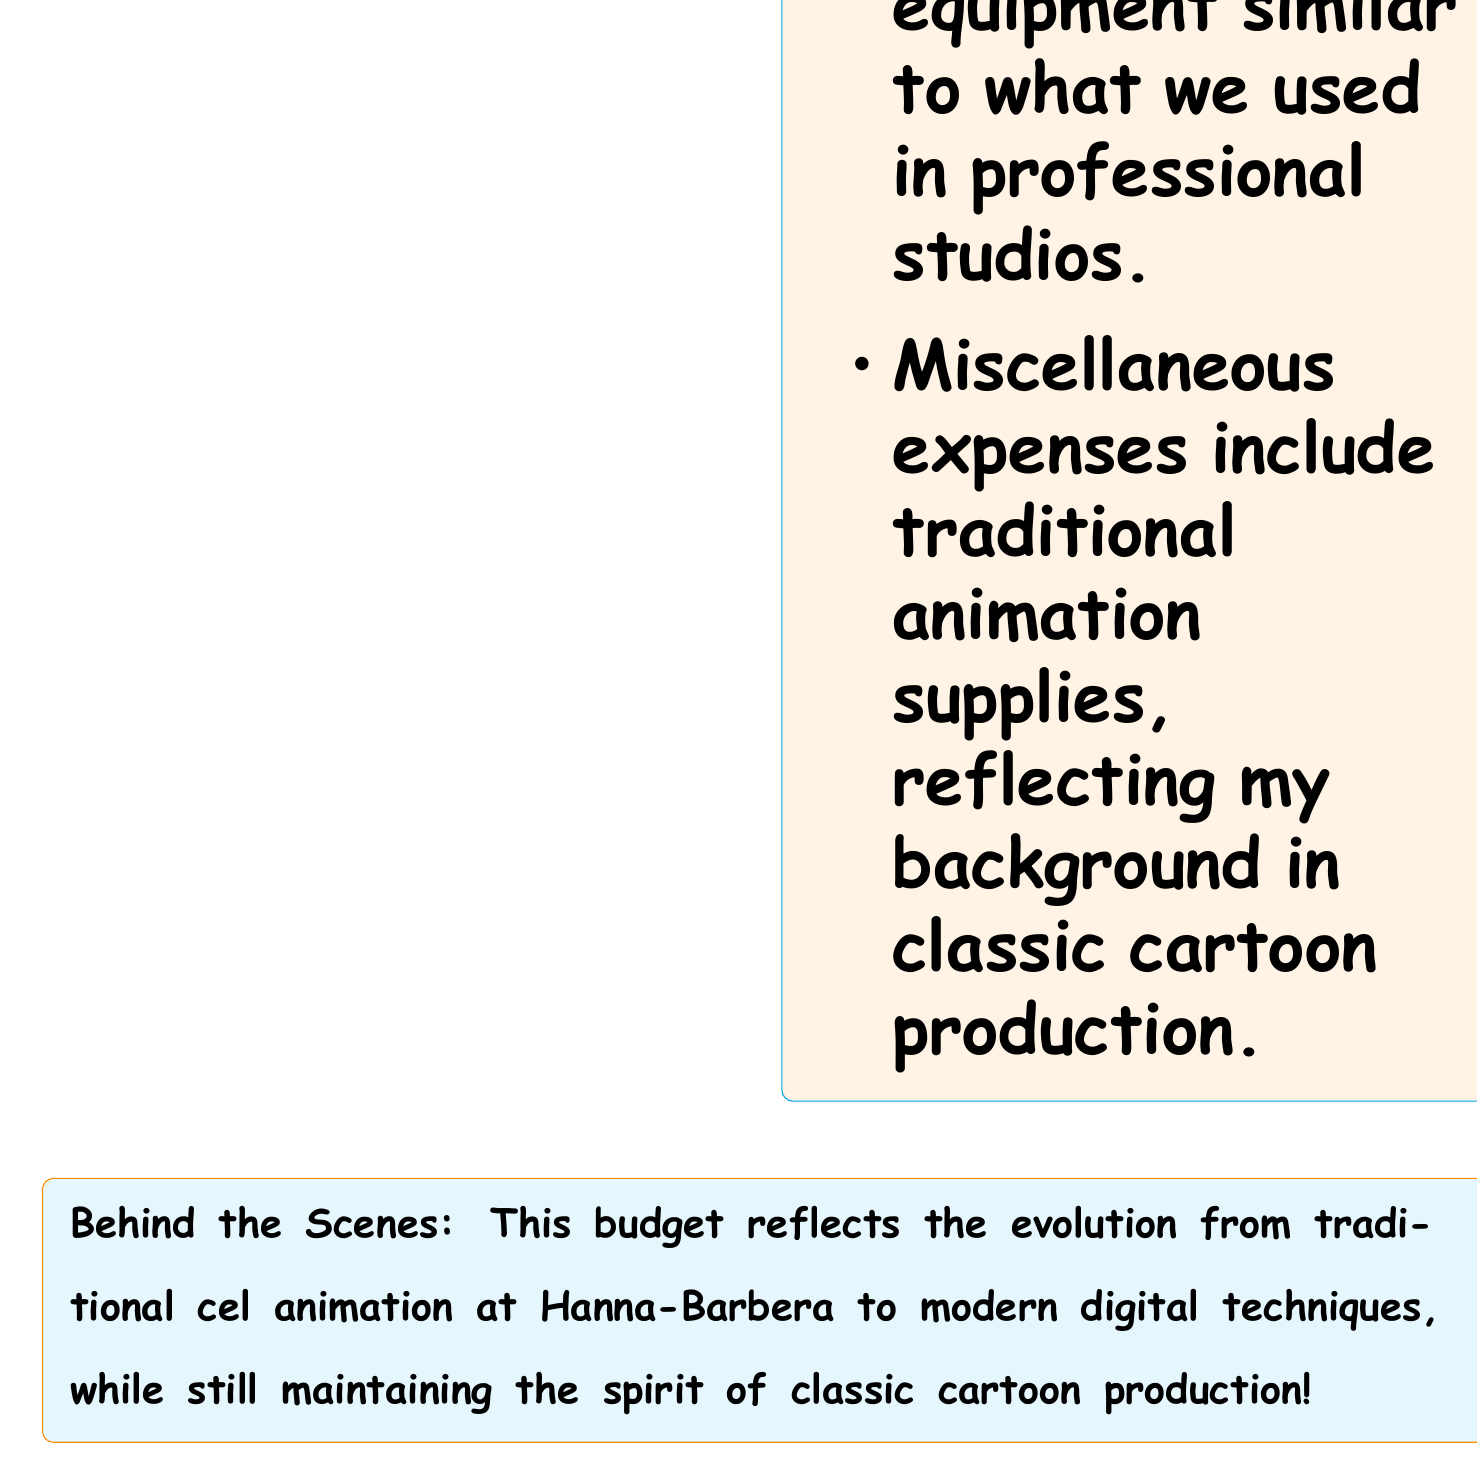What is the total monthly cost? The total monthly cost is calculated by adding all the monthly expenses listed in the document.
Answer: $599.64 How much is the monthly subscription for Adobe Creative Cloud? The monthly subscription for Adobe Creative Cloud is specified in the software subscriptions section of the document.
Answer: $52.99 What is the annual savings for the Wacom Cintiq Pro 24? The document lists the annual savings for the Wacom Cintiq Pro 24 under hardware upgrades.
Answer: $166.67 How much is allocated for cloud storage (Dropbox) monthly? The cloud storage expense is recorded in the miscellaneous section of the budget.
Answer: $11.99 What are the total software subscription costs? To find the total software subscription costs, sum the amounts listed under software subscriptions.
Answer: $150.99 What is the expense for high-speed internet? The expense for high-speed internet is indicated in the utilities section of the document.
Answer: $89.99 How much is budgeted for art supplies? The art supplies cost is included in the miscellaneous section of the budget.
Answer: $30.00 Which software subscription costs the least? The software subscription with the lowest cost is found by comparing the costs listed under software subscriptions.
Answer: TVPaint Animation What does the document reflect about the evolution of animation techniques? The document notes the transition from traditional cel animation to modern digital techniques, showing a blend of both worlds.
Answer: Traditional to digital 